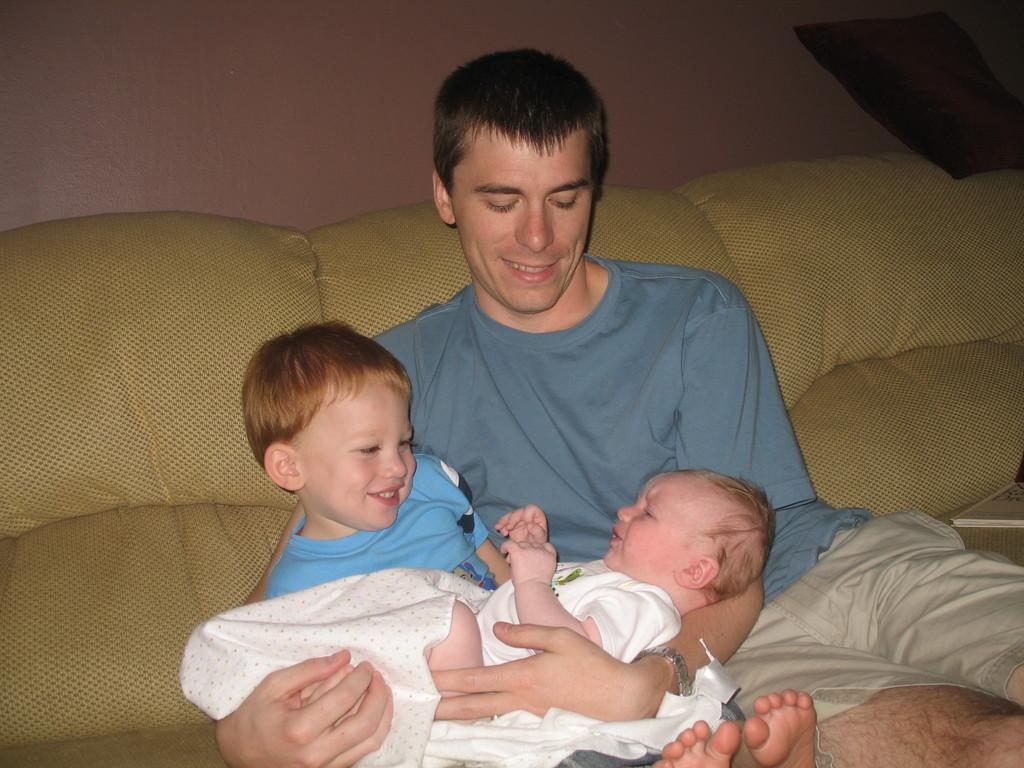Please provide a concise description of this image. In the image we can see there is a man and a kid sitting on the sofa. There is an infant lying on their lap. 